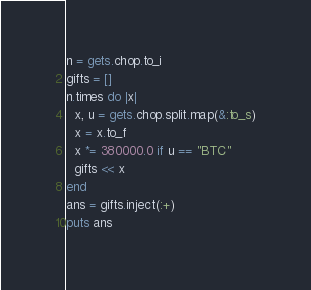<code> <loc_0><loc_0><loc_500><loc_500><_Ruby_>n = gets.chop.to_i
gifts = []
n.times do |x|
  x, u = gets.chop.split.map(&:to_s)
  x = x.to_f
  x *= 380000.0 if u == "BTC"
  gifts << x
end
ans = gifts.inject(:+)
puts ans</code> 